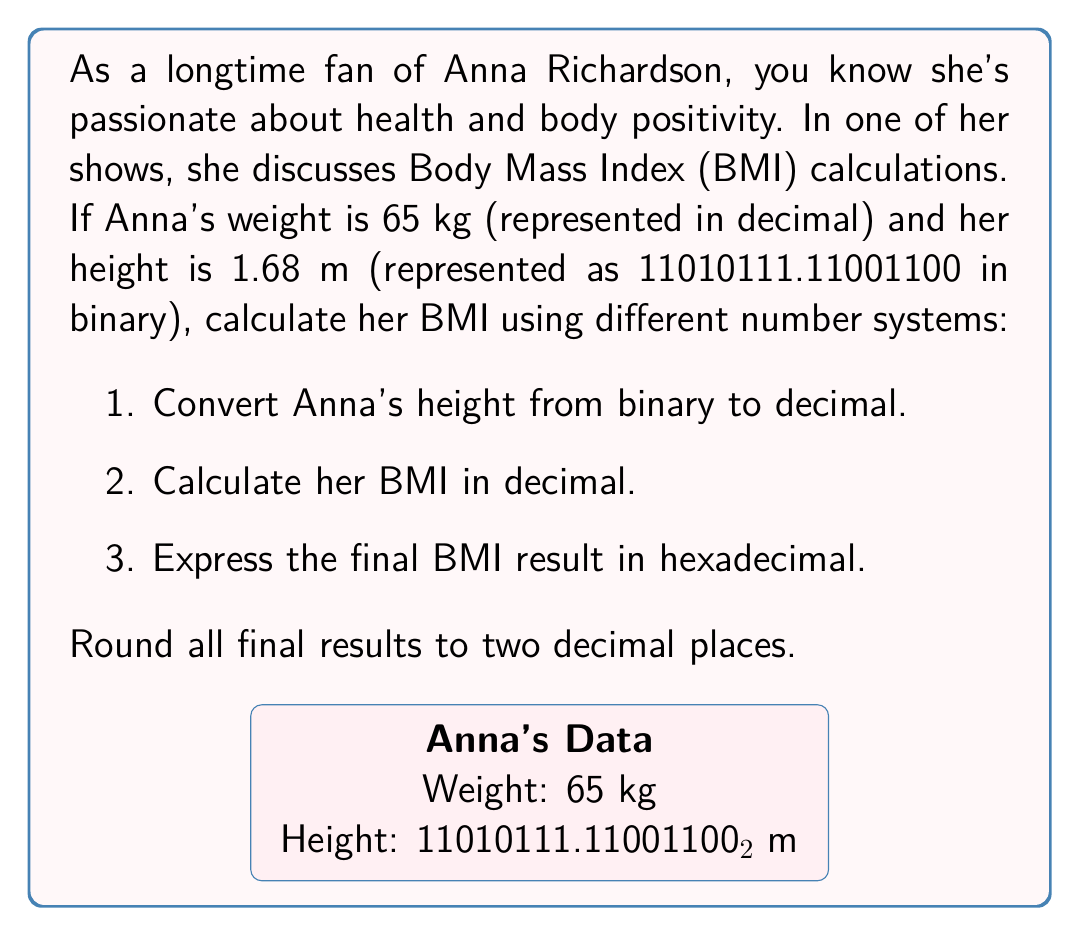Teach me how to tackle this problem. 1. Converting Anna's height from binary to decimal:
   $$11010111.11001100_2 = (1\times2^7 + 1\times2^6 + 0\times2^5 + 1\times2^4 + 0\times2^3 + 1\times2^2 + 1\times2^1 + 1\times2^0) + (1\times2^{-1} + 1\times2^{-2} + 0\times2^{-3} + 0\times2^{-4} + 1\times2^{-5} + 1\times2^{-6} + 0\times2^{-7} + 0\times2^{-8})$$
   $$= 128 + 64 + 16 + 4 + 2 + 1 + 0.5 + 0.25 + 0.03125 + 0.015625$$
   $$= 215 + 0.796875 = 215.796875_{10}$$
   $$\approx 1.68 \text{ m}$$

2. Calculating BMI in decimal:
   BMI formula: $$\text{BMI} = \frac{\text{weight (kg)}}{\text{height (m)}^2}$$
   $$\text{BMI} = \frac{65}{1.68^2} \approx 23.03$$

3. Expressing the BMI result in hexadecimal:
   To convert 23.03 to hexadecimal, we separate the integer and fractional parts:
   Integer part: $23_{10} = 17_{16}$
   Fractional part: $0.03 \times 16 = 0.48$, take $4$ and continue
   $0.48 \times 16 = 7.68$, take $7$ and stop (2 decimal places)
   
   Therefore, $23.03_{10} \approx 17.4C_{16}$
Answer: $17.4C_{16}$ 